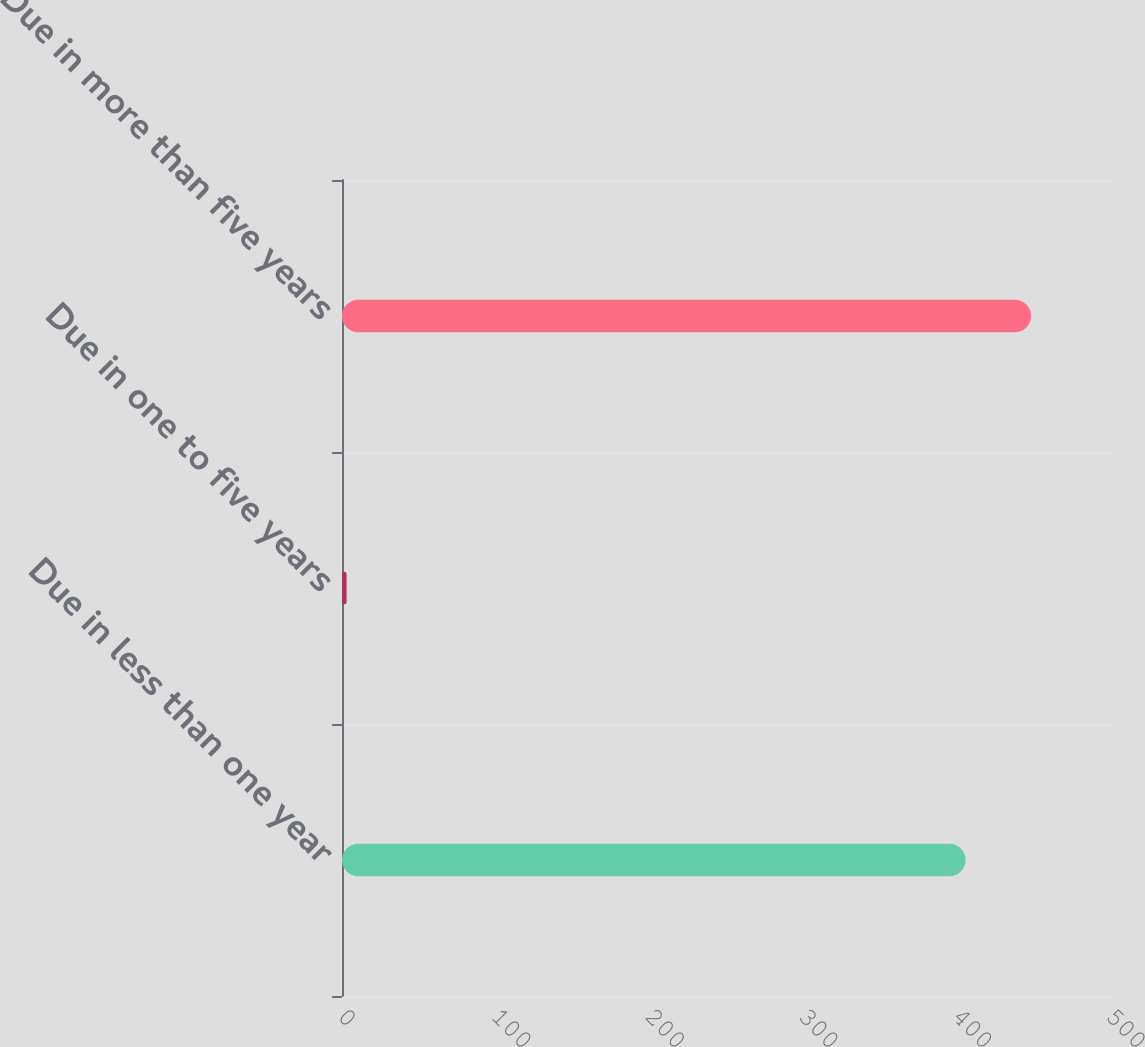Convert chart to OTSL. <chart><loc_0><loc_0><loc_500><loc_500><bar_chart><fcel>Due in less than one year<fcel>Due in one to five years<fcel>Due in more than five years<nl><fcel>406<fcel>3<fcel>448.6<nl></chart> 